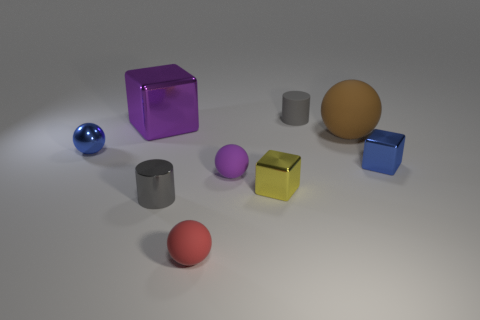What number of other objects are the same shape as the big purple shiny thing?
Offer a terse response. 2. Do the matte thing in front of the gray metal thing and the purple rubber object have the same shape?
Ensure brevity in your answer.  Yes. There is a brown thing; are there any brown balls in front of it?
Offer a terse response. No. How many large objects are gray metal cylinders or blue metal blocks?
Provide a succinct answer. 0. Is the material of the yellow thing the same as the large ball?
Make the answer very short. No. Are there any small balls that have the same color as the small shiny cylinder?
Your answer should be compact. No. What is the size of the brown thing that is the same material as the red ball?
Keep it short and to the point. Large. What shape is the tiny blue metal object to the right of the tiny ball that is to the left of the metal cube behind the blue sphere?
Ensure brevity in your answer.  Cube. The purple object that is the same shape as the tiny yellow metal thing is what size?
Your response must be concise. Large. There is a block that is left of the brown matte ball and on the right side of the gray shiny cylinder; what size is it?
Provide a succinct answer. Small. 